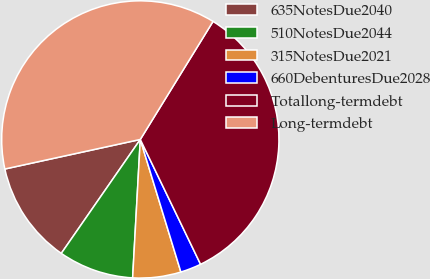Convert chart to OTSL. <chart><loc_0><loc_0><loc_500><loc_500><pie_chart><fcel>635NotesDue2040<fcel>510NotesDue2044<fcel>315NotesDue2021<fcel>660DebenturesDue2028<fcel>Totallong-termdebt<fcel>Long-termdebt<nl><fcel>11.93%<fcel>8.77%<fcel>5.61%<fcel>2.43%<fcel>34.05%<fcel>37.21%<nl></chart> 